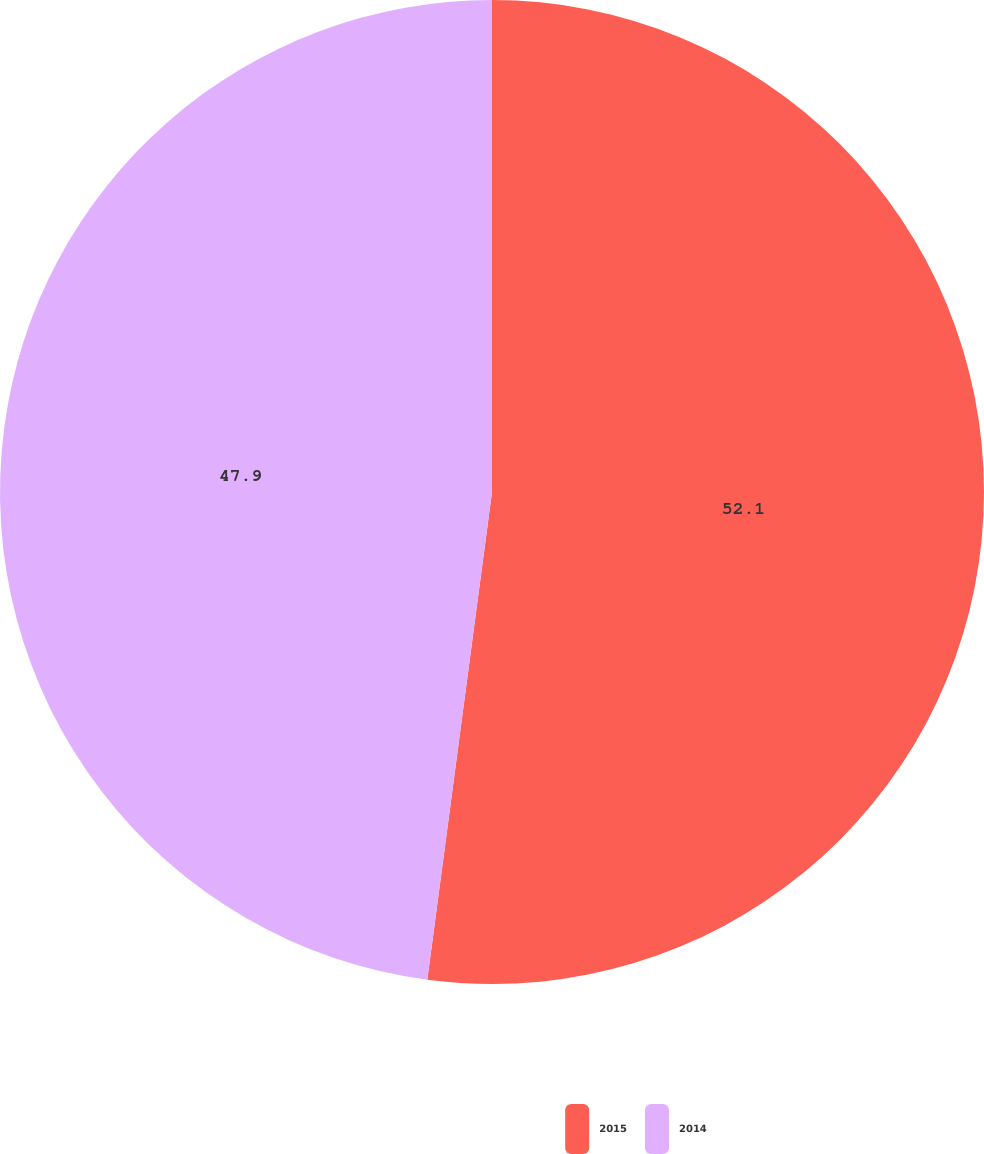Convert chart. <chart><loc_0><loc_0><loc_500><loc_500><pie_chart><fcel>2015<fcel>2014<nl><fcel>52.1%<fcel>47.9%<nl></chart> 